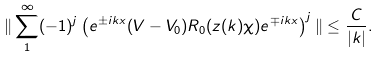Convert formula to latex. <formula><loc_0><loc_0><loc_500><loc_500>\| \sum _ { 1 } ^ { \infty } ( - 1 ) ^ { j } \left ( e ^ { \pm i k x } ( V - V _ { 0 } ) R _ { 0 } ( z ( k ) \chi ) e ^ { \mp i k x } \right ) ^ { j } \| \leq \frac { C } { | k | } .</formula> 